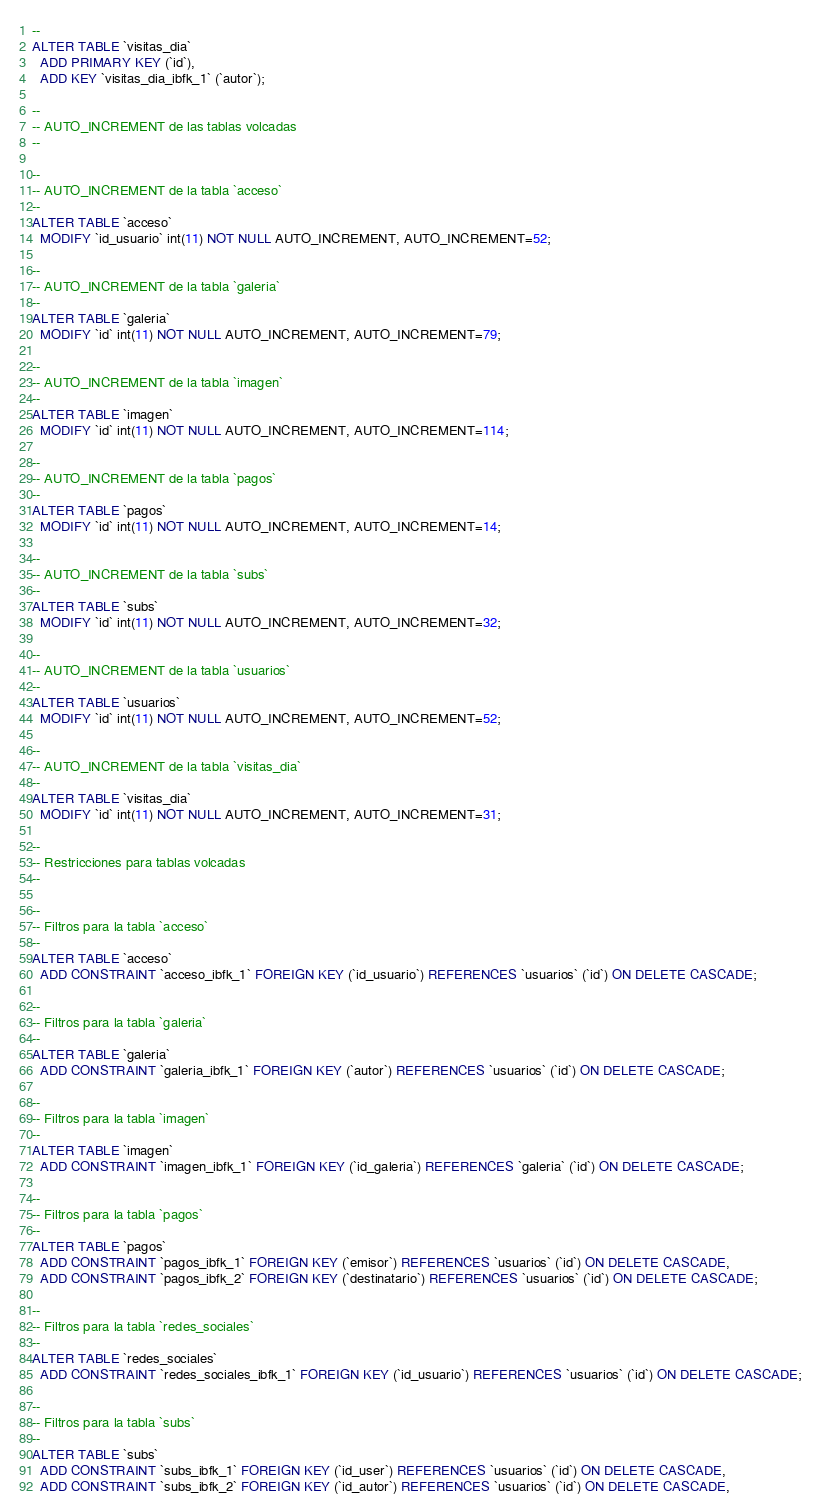Convert code to text. <code><loc_0><loc_0><loc_500><loc_500><_SQL_>--
ALTER TABLE `visitas_dia`
  ADD PRIMARY KEY (`id`),
  ADD KEY `visitas_dia_ibfk_1` (`autor`);

--
-- AUTO_INCREMENT de las tablas volcadas
--

--
-- AUTO_INCREMENT de la tabla `acceso`
--
ALTER TABLE `acceso`
  MODIFY `id_usuario` int(11) NOT NULL AUTO_INCREMENT, AUTO_INCREMENT=52;

--
-- AUTO_INCREMENT de la tabla `galeria`
--
ALTER TABLE `galeria`
  MODIFY `id` int(11) NOT NULL AUTO_INCREMENT, AUTO_INCREMENT=79;

--
-- AUTO_INCREMENT de la tabla `imagen`
--
ALTER TABLE `imagen`
  MODIFY `id` int(11) NOT NULL AUTO_INCREMENT, AUTO_INCREMENT=114;

--
-- AUTO_INCREMENT de la tabla `pagos`
--
ALTER TABLE `pagos`
  MODIFY `id` int(11) NOT NULL AUTO_INCREMENT, AUTO_INCREMENT=14;

--
-- AUTO_INCREMENT de la tabla `subs`
--
ALTER TABLE `subs`
  MODIFY `id` int(11) NOT NULL AUTO_INCREMENT, AUTO_INCREMENT=32;

--
-- AUTO_INCREMENT de la tabla `usuarios`
--
ALTER TABLE `usuarios`
  MODIFY `id` int(11) NOT NULL AUTO_INCREMENT, AUTO_INCREMENT=52;

--
-- AUTO_INCREMENT de la tabla `visitas_dia`
--
ALTER TABLE `visitas_dia`
  MODIFY `id` int(11) NOT NULL AUTO_INCREMENT, AUTO_INCREMENT=31;

--
-- Restricciones para tablas volcadas
--

--
-- Filtros para la tabla `acceso`
--
ALTER TABLE `acceso`
  ADD CONSTRAINT `acceso_ibfk_1` FOREIGN KEY (`id_usuario`) REFERENCES `usuarios` (`id`) ON DELETE CASCADE;

--
-- Filtros para la tabla `galeria`
--
ALTER TABLE `galeria`
  ADD CONSTRAINT `galeria_ibfk_1` FOREIGN KEY (`autor`) REFERENCES `usuarios` (`id`) ON DELETE CASCADE;

--
-- Filtros para la tabla `imagen`
--
ALTER TABLE `imagen`
  ADD CONSTRAINT `imagen_ibfk_1` FOREIGN KEY (`id_galeria`) REFERENCES `galeria` (`id`) ON DELETE CASCADE;

--
-- Filtros para la tabla `pagos`
--
ALTER TABLE `pagos`
  ADD CONSTRAINT `pagos_ibfk_1` FOREIGN KEY (`emisor`) REFERENCES `usuarios` (`id`) ON DELETE CASCADE,
  ADD CONSTRAINT `pagos_ibfk_2` FOREIGN KEY (`destinatario`) REFERENCES `usuarios` (`id`) ON DELETE CASCADE;

--
-- Filtros para la tabla `redes_sociales`
--
ALTER TABLE `redes_sociales`
  ADD CONSTRAINT `redes_sociales_ibfk_1` FOREIGN KEY (`id_usuario`) REFERENCES `usuarios` (`id`) ON DELETE CASCADE;

--
-- Filtros para la tabla `subs`
--
ALTER TABLE `subs`
  ADD CONSTRAINT `subs_ibfk_1` FOREIGN KEY (`id_user`) REFERENCES `usuarios` (`id`) ON DELETE CASCADE,
  ADD CONSTRAINT `subs_ibfk_2` FOREIGN KEY (`id_autor`) REFERENCES `usuarios` (`id`) ON DELETE CASCADE,</code> 